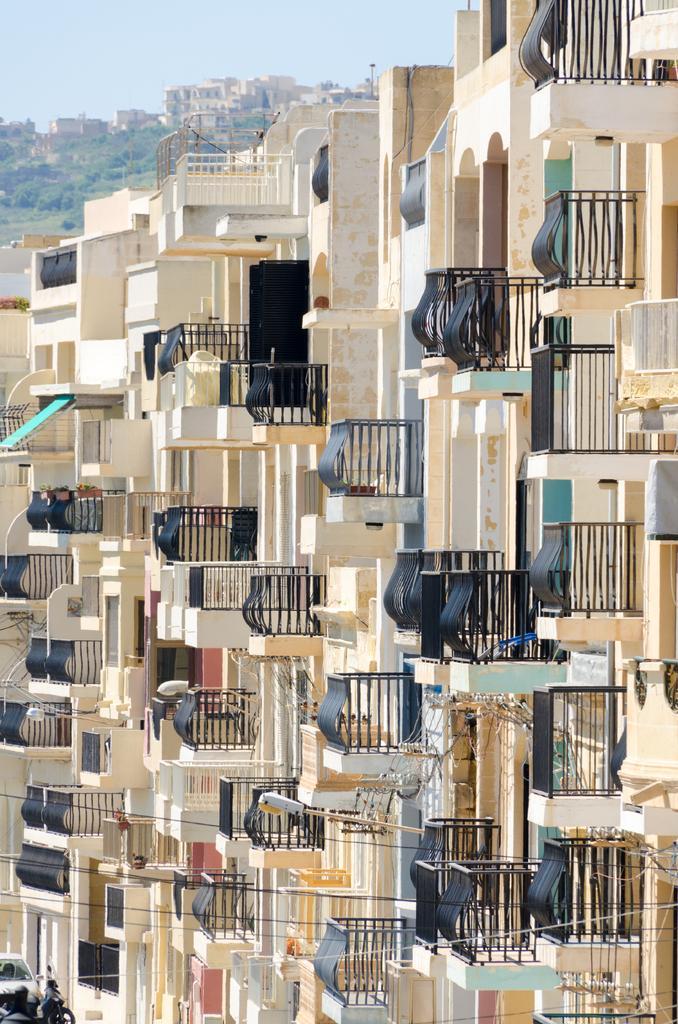Describe this image in one or two sentences. In this picture I can see the buildings in the middle, in the background there are trees, at the top I can see the sky. 